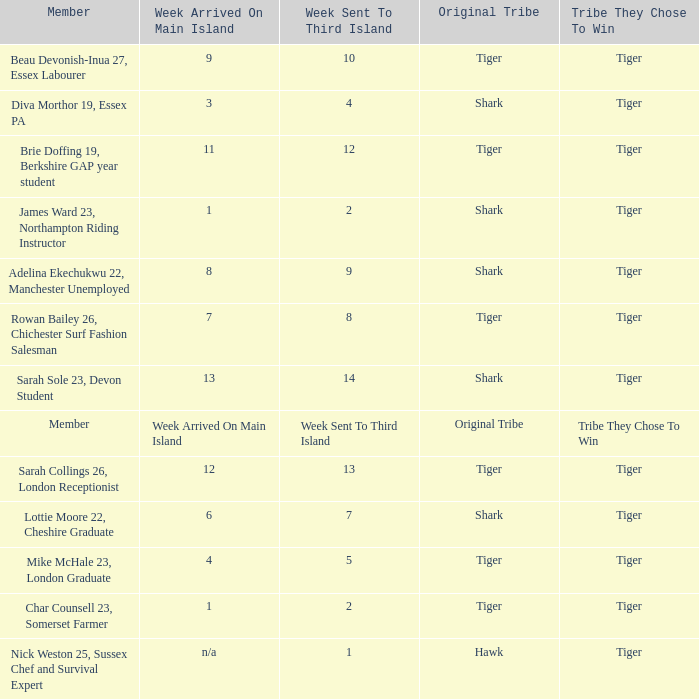Parse the table in full. {'header': ['Member', 'Week Arrived On Main Island', 'Week Sent To Third Island', 'Original Tribe', 'Tribe They Chose To Win'], 'rows': [['Beau Devonish-Inua 27, Essex Labourer', '9', '10', 'Tiger', 'Tiger'], ['Diva Morthor 19, Essex PA', '3', '4', 'Shark', 'Tiger'], ['Brie Doffing 19, Berkshire GAP year student', '11', '12', 'Tiger', 'Tiger'], ['James Ward 23, Northampton Riding Instructor', '1', '2', 'Shark', 'Tiger'], ['Adelina Ekechukwu 22, Manchester Unemployed', '8', '9', 'Shark', 'Tiger'], ['Rowan Bailey 26, Chichester Surf Fashion Salesman', '7', '8', 'Tiger', 'Tiger'], ['Sarah Sole 23, Devon Student', '13', '14', 'Shark', 'Tiger'], ['Member', 'Week Arrived On Main Island', 'Week Sent To Third Island', 'Original Tribe', 'Tribe They Chose To Win'], ['Sarah Collings 26, London Receptionist', '12', '13', 'Tiger', 'Tiger'], ['Lottie Moore 22, Cheshire Graduate', '6', '7', 'Shark', 'Tiger'], ['Mike McHale 23, London Graduate', '4', '5', 'Tiger', 'Tiger'], ['Char Counsell 23, Somerset Farmer', '1', '2', 'Tiger', 'Tiger'], ['Nick Weston 25, Sussex Chef and Survival Expert', 'n/a', '1', 'Hawk', 'Tiger']]} What week was the member who arrived on the main island in week 6 sent to the third island? 7.0. 